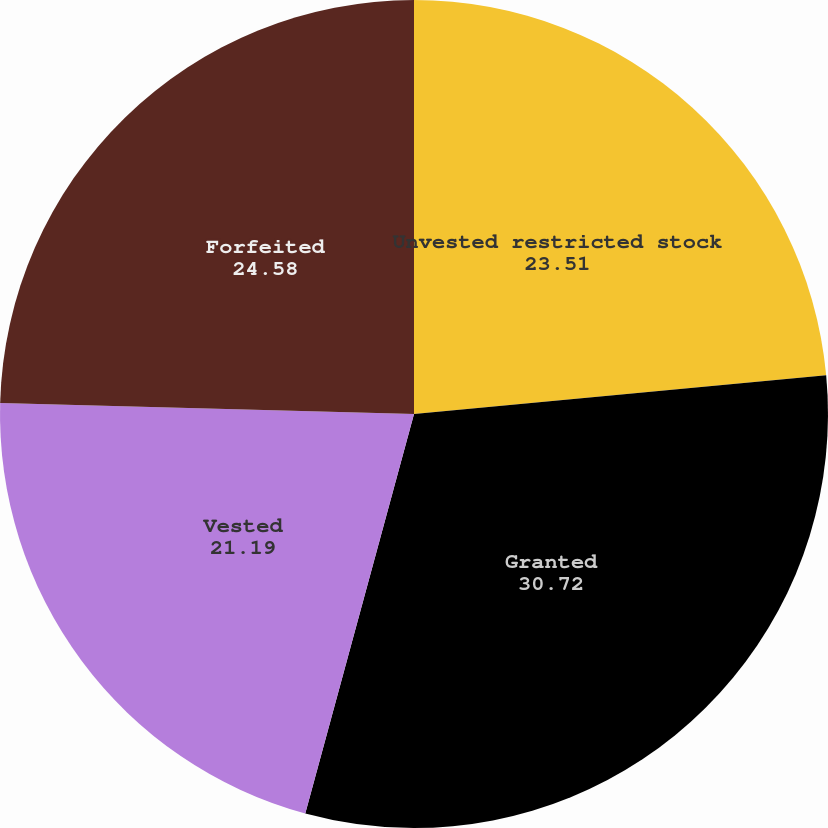Convert chart. <chart><loc_0><loc_0><loc_500><loc_500><pie_chart><fcel>Unvested restricted stock<fcel>Granted<fcel>Vested<fcel>Forfeited<nl><fcel>23.51%<fcel>30.72%<fcel>21.19%<fcel>24.58%<nl></chart> 